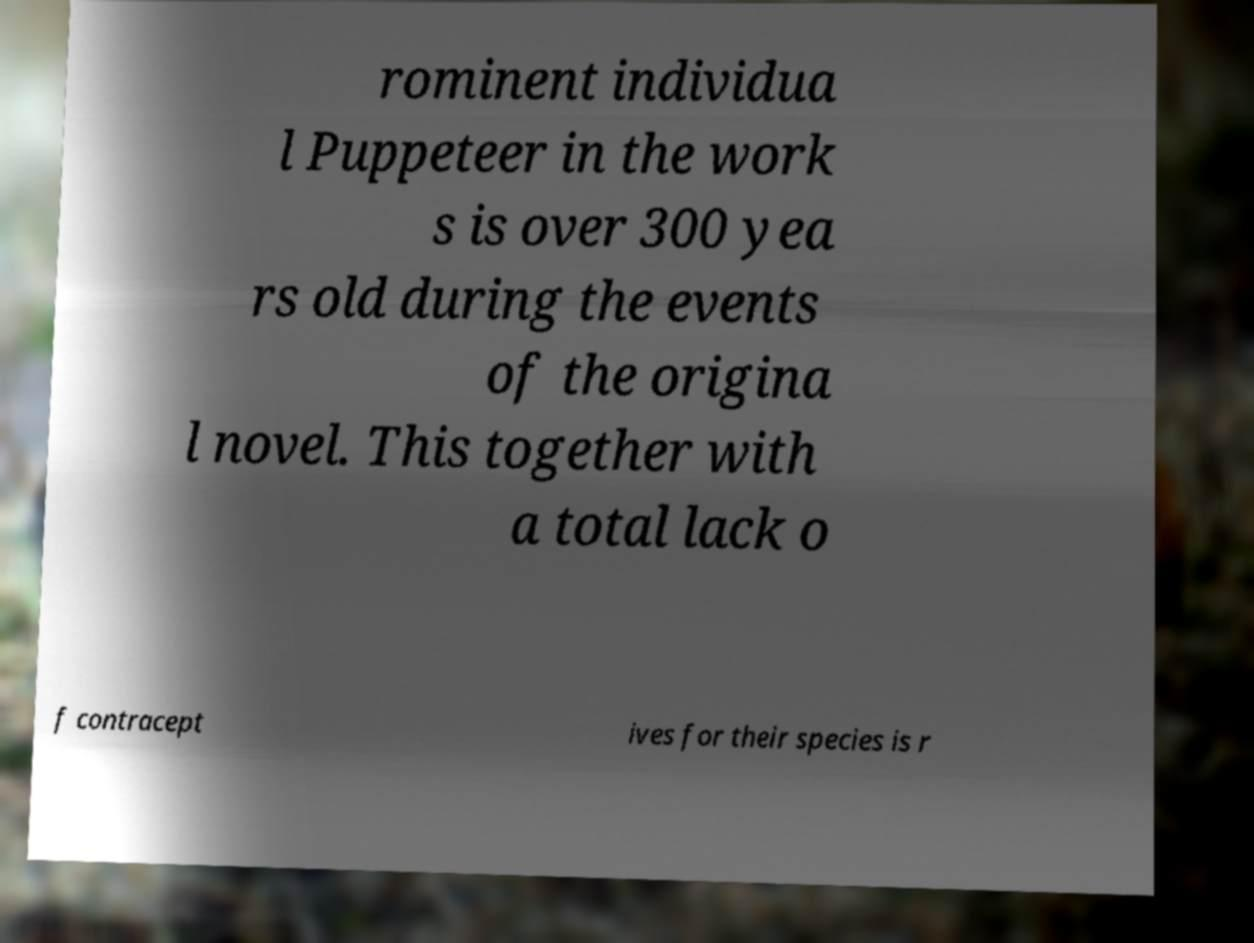Can you accurately transcribe the text from the provided image for me? rominent individua l Puppeteer in the work s is over 300 yea rs old during the events of the origina l novel. This together with a total lack o f contracept ives for their species is r 